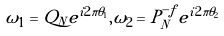<formula> <loc_0><loc_0><loc_500><loc_500>\omega _ { 1 } = Q _ { N } e ^ { i 2 \pi \theta _ { 1 } } , \omega _ { 2 } = P _ { N } ^ { - f } e ^ { i 2 \pi \theta _ { 2 } }</formula> 